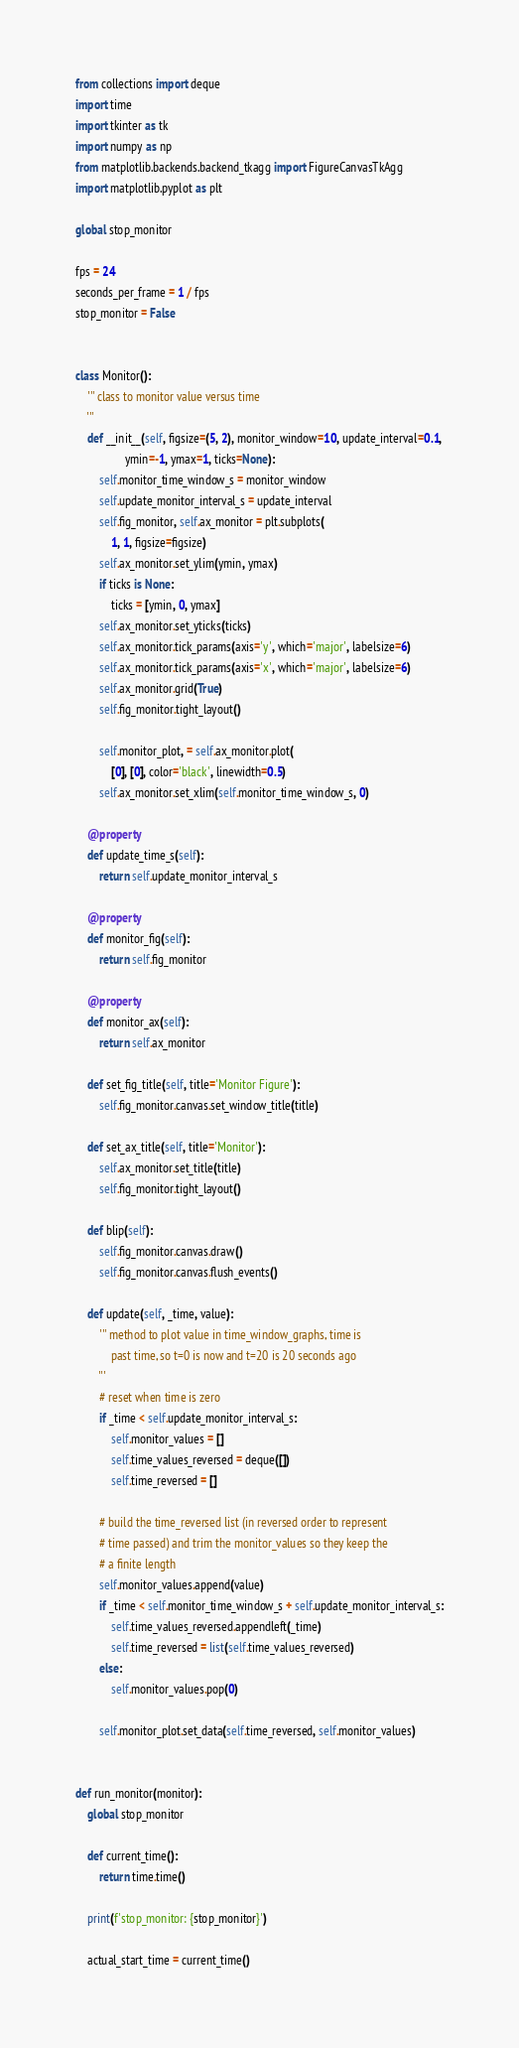<code> <loc_0><loc_0><loc_500><loc_500><_Python_>from collections import deque
import time
import tkinter as tk
import numpy as np
from matplotlib.backends.backend_tkagg import FigureCanvasTkAgg
import matplotlib.pyplot as plt

global stop_monitor

fps = 24
seconds_per_frame = 1 / fps
stop_monitor = False


class Monitor():
    ''' class to monitor value versus time
    '''
    def __init__(self, figsize=(5, 2), monitor_window=10, update_interval=0.1,
                 ymin=-1, ymax=1, ticks=None):
        self.monitor_time_window_s = monitor_window
        self.update_monitor_interval_s = update_interval
        self.fig_monitor, self.ax_monitor = plt.subplots(
            1, 1, figsize=figsize)
        self.ax_monitor.set_ylim(ymin, ymax)
        if ticks is None:
            ticks = [ymin, 0, ymax]
        self.ax_monitor.set_yticks(ticks)
        self.ax_monitor.tick_params(axis='y', which='major', labelsize=6)
        self.ax_monitor.tick_params(axis='x', which='major', labelsize=6)
        self.ax_monitor.grid(True)
        self.fig_monitor.tight_layout()

        self.monitor_plot, = self.ax_monitor.plot(
            [0], [0], color='black', linewidth=0.5)
        self.ax_monitor.set_xlim(self.monitor_time_window_s, 0)

    @property
    def update_time_s(self):
        return self.update_monitor_interval_s

    @property
    def monitor_fig(self):
        return self.fig_monitor

    @property
    def monitor_ax(self):
        return self.ax_monitor

    def set_fig_title(self, title='Monitor Figure'):
        self.fig_monitor.canvas.set_window_title(title)

    def set_ax_title(self, title='Monitor'):
        self.ax_monitor.set_title(title)
        self.fig_monitor.tight_layout()

    def blip(self):
        self.fig_monitor.canvas.draw()
        self.fig_monitor.canvas.flush_events()

    def update(self, _time, value):
        ''' method to plot value in time_window_graphs, time is
            past time, so t=0 is now and t=20 is 20 seconds ago
        '''
        # reset when time is zero
        if _time < self.update_monitor_interval_s:
            self.monitor_values = []
            self.time_values_reversed = deque([])
            self.time_reversed = []

        # build the time_reversed list (in reversed order to represent
        # time passed) and trim the monitor_values so they keep the
        # a finite length
        self.monitor_values.append(value)
        if _time < self.monitor_time_window_s + self.update_monitor_interval_s:
            self.time_values_reversed.appendleft(_time)
            self.time_reversed = list(self.time_values_reversed)
        else:
            self.monitor_values.pop(0)

        self.monitor_plot.set_data(self.time_reversed, self.monitor_values)


def run_monitor(monitor):
    global stop_monitor

    def current_time():
        return time.time()

    print(f'stop_monitor: {stop_monitor}')

    actual_start_time = current_time()</code> 